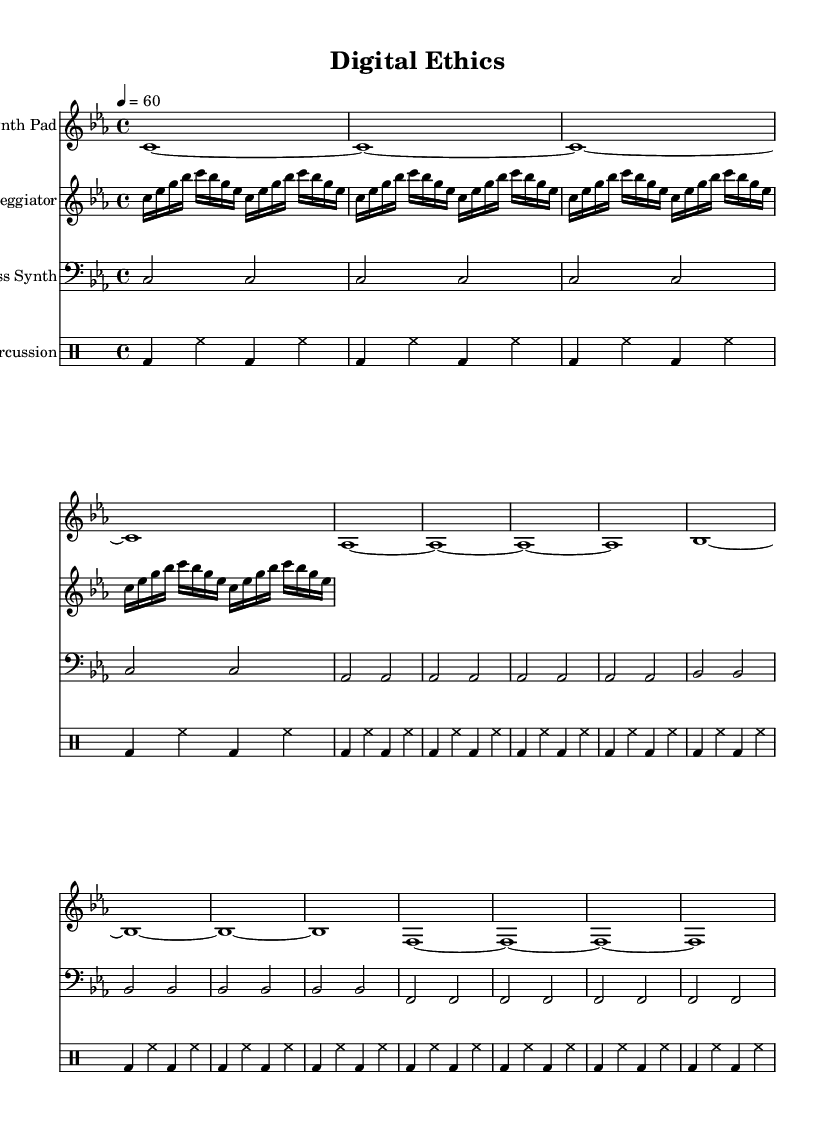What is the key signature of this music? The key signature is C minor, indicated by three flat symbols (B♭, E♭, and A♭) on the staff.
Answer: C minor What is the time signature of this piece? The time signature is 4/4, which means there are four beats in each measure and the quarter note gets one beat.
Answer: 4/4 What is the tempo of the music? The tempo is indicated as 60 beats per minute, which dictates the speed of the piece.
Answer: 60 How many measures does the Synth Pad part contain? The Synth Pad part contains four measures, as indicated by the grouping of notes and bars shown on the staff.
Answer: Four measures Which instrument plays the arpeggio? The arpeggiator is the instrument that plays the arpeggio pattern, as shown on the corresponding staff labeled "Arpeggiator".
Answer: Arpeggiator What type of rhythm is used in the percussion section? The rhythm in the percussion section consists mainly of bass drum and hi-hat, repeating every measure with a structured pattern.
Answer: Bass drum and hi-hat How is the dynamic level indicated in this piece? The dynamic level is represented by the absence of specific dynamics, suggesting a soft and ambient approach typical of ambient electronic music.
Answer: Absence of dynamics 